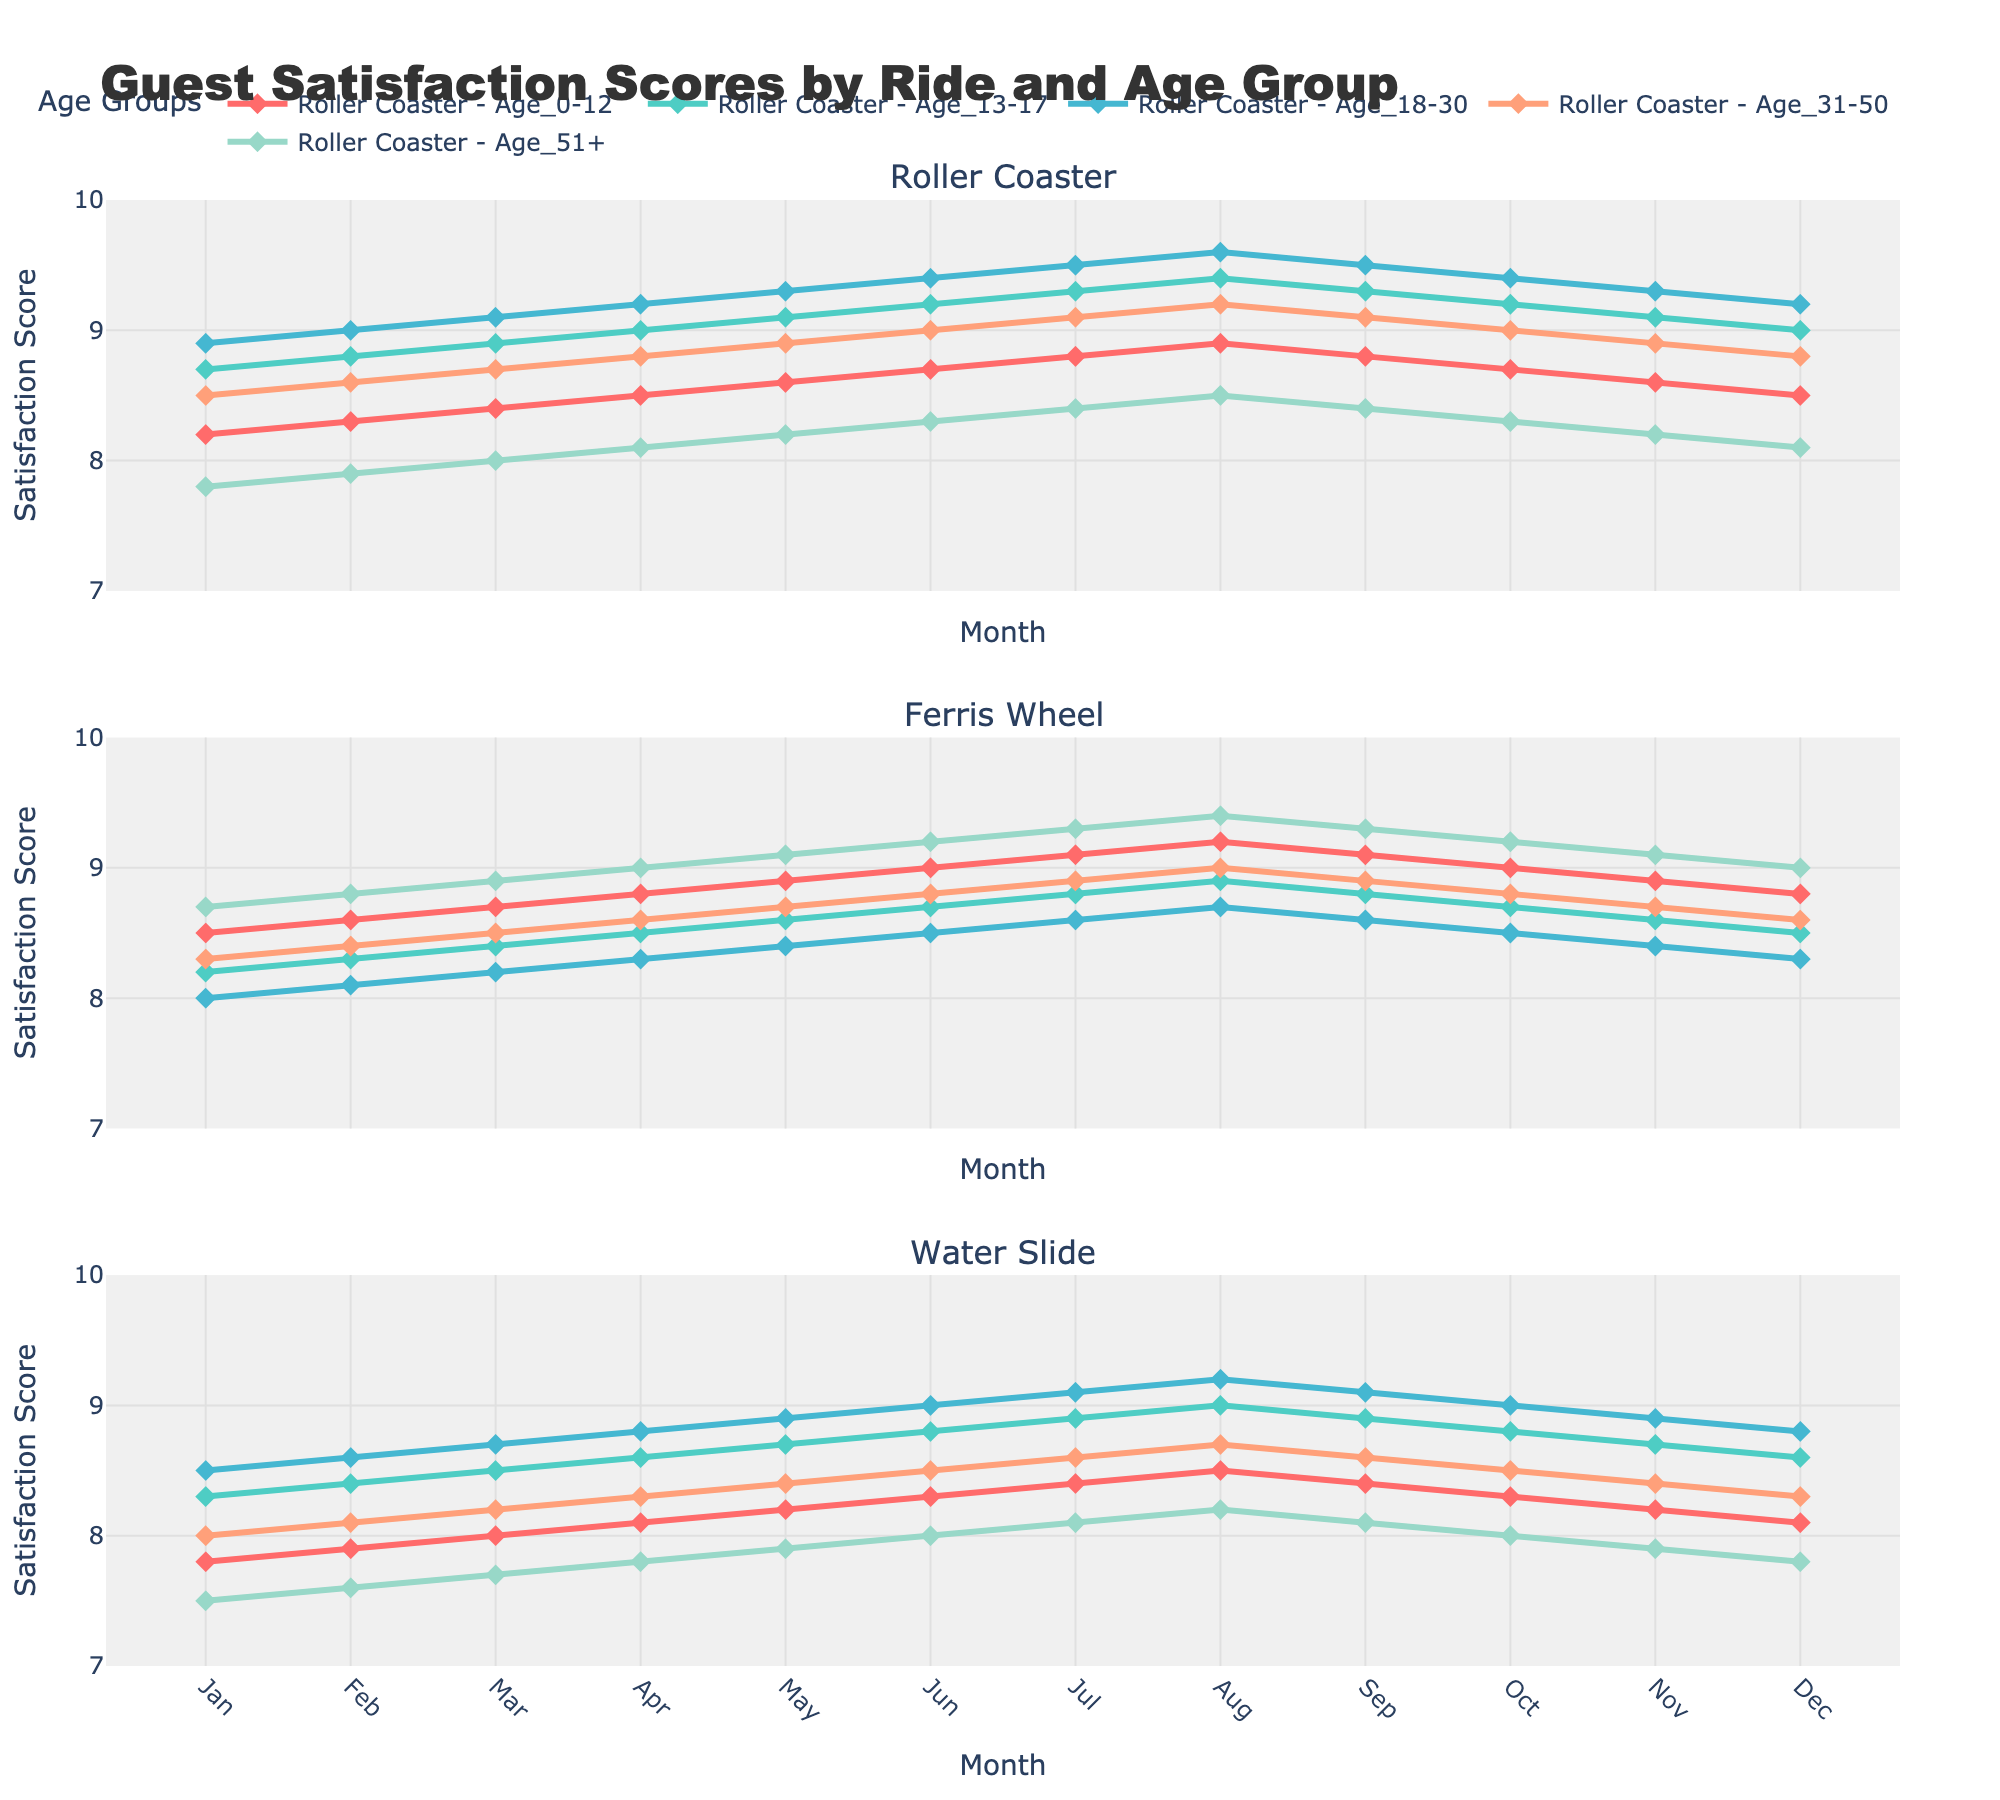Which ride had the highest satisfaction score among the Age 18-30 group in August? The line representing the Age 18-30 group in August will be examined for each ride. The Water Slide scored 9.2, the Roller Coaster 9.6, and the Ferris Wheel 8.7. The highest score is from the Roller Coaster.
Answer: Roller Coaster Between June and August, how did the satisfaction scores for the Ferris Wheel change for the Age 0-12 group? For the Ferris Wheel in the Age 0-12 group, the scores in June, July, and August are 9.0, 9.1, and 9.2 respectively. The scores increased slightly each month.
Answer: Increased Which age group had the smallest increase in satisfaction scores from January to December for the Roller Coaster? For each age group, we look at the difference between January and December scores: Age 0-12 (8.5 - 8.2 = 0.3), Age 13-17 (9.0 - 8.7 = 0.3), Age 18-30 (9.2 - 8.9 = 0.3), Age 31-50 (8.8 - 8.5 = 0.3), Age 51+ (8.1 - 7.8 = 0.3). All groups had the same increase of 0.3, so none had the smallest increase over others.
Answer: Age 0-12, Age 13-17, Age 18-30, Age 31-50, Age 51+ From which month did the Water Slide see a consistent increase in satisfaction scores across all age groups until August? Examine the scores from month to month: from January to May, not all age groups show consistent increases; starting from May to August, each month sees an increase in scores across all age groups.
Answer: May In July, which ride had the lowest satisfaction score from the Age 51+ group? Examine the July scores for the Age 51+ group for all rides: Roller Coaster (8.4), Ferris Wheel (9.3), Water Slide (8.1). The Water Slide has the lowest score.
Answer: Water Slide Compare the satisfaction scores of Age 31-50 in April between the Roller Coaster and the Water Slide. Which one is higher and by how much? The satisfaction score for Age 31-50 in April for the Roller Coaster is 8.8 and for the Water Slide is 8.3. The Roller Coaster score is higher. The difference is 8.8 - 8.3 = 0.5.
Answer: Roller Coaster, 0.5 What is the trend in satisfaction scores for the Age 13-17 group in the Ferris Wheel throughout the year? The scores for Age 13-17 at the Ferris Wheel: Jan (8.2), Feb (8.3), Mar (8.4), Apr (8.5), May (8.6), Jun (8.7), Jul (8.8), Aug (8.9), Sep (8.8), Oct (8.7), Nov (8.6), Dec (8.5). The scores generally increase from Jan to Aug and then decrease from Aug to Dec.
Answer: Increase until Aug, then decrease Which ride had an equal score of 9.2 in May for both Age 13-17 and Age 18-30 groups? Look at the May scores: Roller Coaster (Age 13-17:9.1, Age 18-30:9.3), Ferris Wheel (Age 13-17:8.6, Age 18-30:8.4), Water Slide (Age 13-17:8.7, Age 18-30:8.9). None of the rides had a score of 9.2 in both groups.
Answer: None 